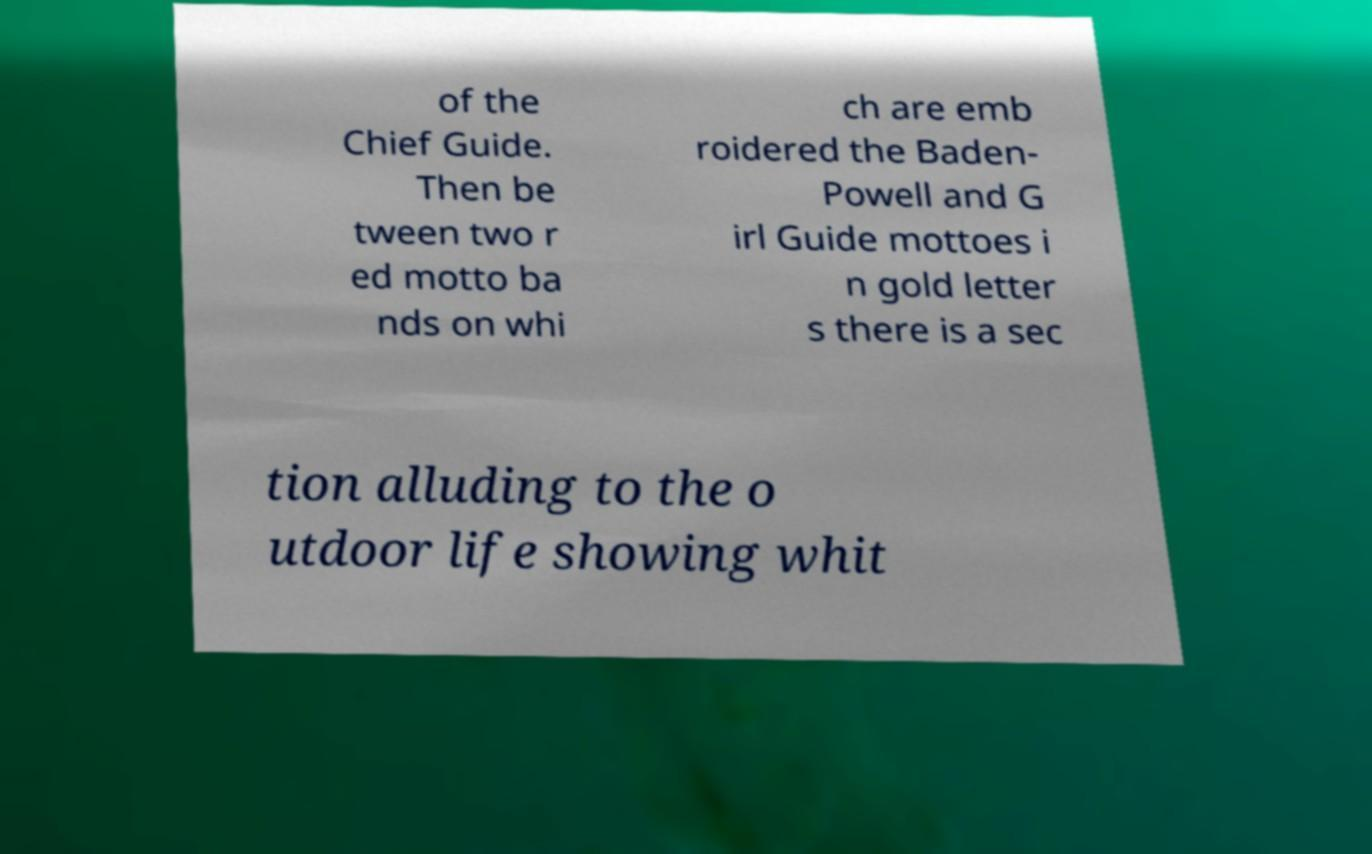For documentation purposes, I need the text within this image transcribed. Could you provide that? of the Chief Guide. Then be tween two r ed motto ba nds on whi ch are emb roidered the Baden- Powell and G irl Guide mottoes i n gold letter s there is a sec tion alluding to the o utdoor life showing whit 